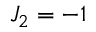Convert formula to latex. <formula><loc_0><loc_0><loc_500><loc_500>{ { J } _ { 2 } } = - 1</formula> 